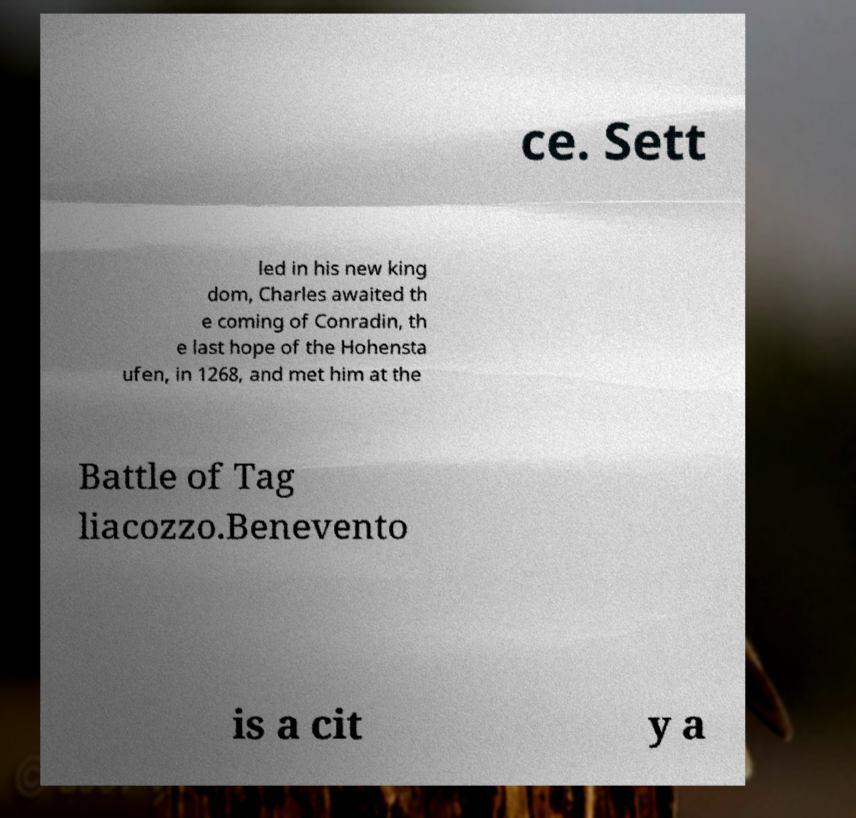Could you extract and type out the text from this image? ce. Sett led in his new king dom, Charles awaited th e coming of Conradin, th e last hope of the Hohensta ufen, in 1268, and met him at the Battle of Tag liacozzo.Benevento is a cit y a 